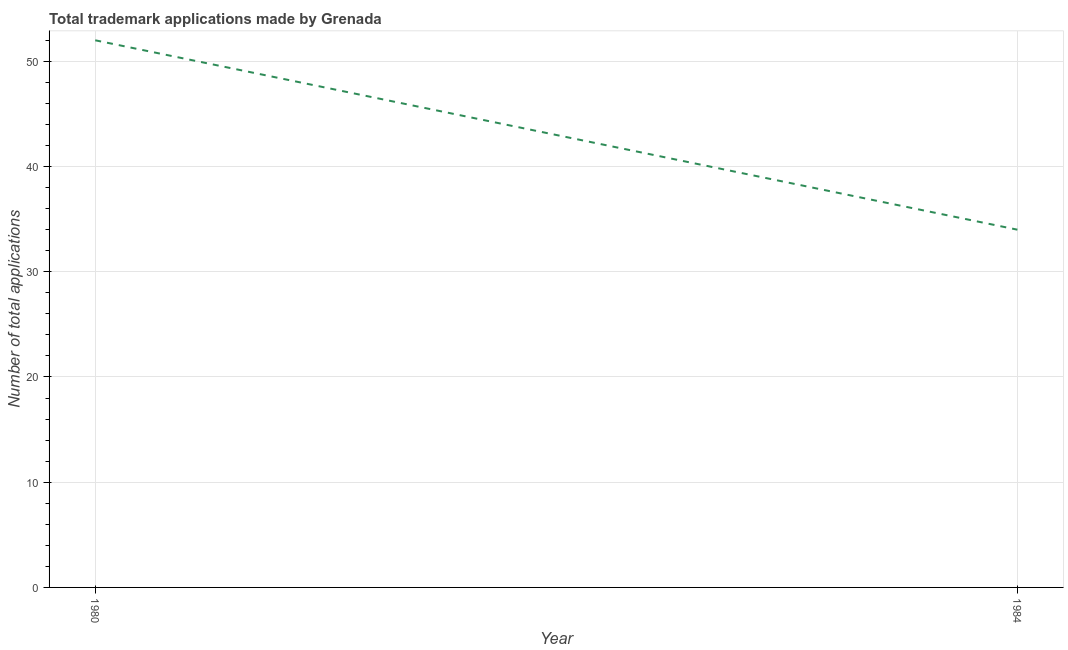What is the number of trademark applications in 1984?
Keep it short and to the point. 34. Across all years, what is the maximum number of trademark applications?
Offer a terse response. 52. Across all years, what is the minimum number of trademark applications?
Your answer should be compact. 34. In which year was the number of trademark applications minimum?
Offer a terse response. 1984. What is the sum of the number of trademark applications?
Offer a terse response. 86. What is the difference between the number of trademark applications in 1980 and 1984?
Make the answer very short. 18. Do a majority of the years between 1980 and 1984 (inclusive) have number of trademark applications greater than 18 ?
Provide a short and direct response. Yes. What is the ratio of the number of trademark applications in 1980 to that in 1984?
Keep it short and to the point. 1.53. Is the number of trademark applications in 1980 less than that in 1984?
Provide a succinct answer. No. How many lines are there?
Provide a succinct answer. 1. How many years are there in the graph?
Your answer should be very brief. 2. What is the difference between two consecutive major ticks on the Y-axis?
Your answer should be compact. 10. What is the title of the graph?
Ensure brevity in your answer.  Total trademark applications made by Grenada. What is the label or title of the Y-axis?
Your answer should be compact. Number of total applications. What is the Number of total applications in 1980?
Provide a short and direct response. 52. What is the ratio of the Number of total applications in 1980 to that in 1984?
Your response must be concise. 1.53. 